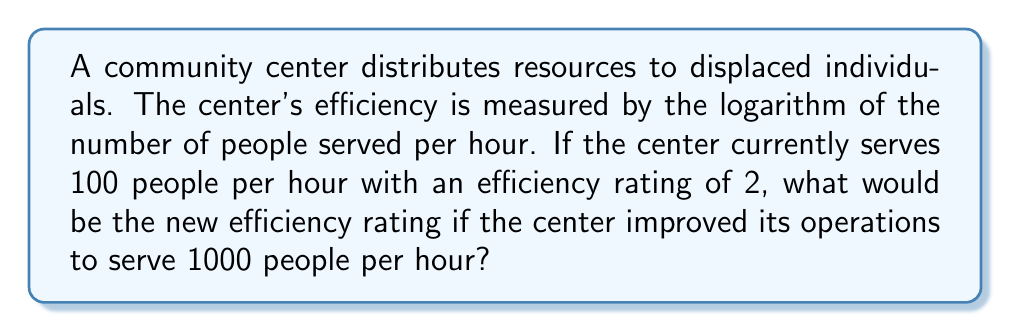Help me with this question. Let's approach this step-by-step:

1) We're given that the efficiency rating is based on the logarithm of the number of people served per hour.

2) The current situation:
   - 100 people served per hour
   - Efficiency rating of 2

3) This means that:
   $$ \log_{b}(100) = 2 $$
   Where $b$ is the base of the logarithm.

4) To find the base, we can solve this equation:
   $$ b^2 = 100 $$
   $$ b = \sqrt{100} = 10 $$

5) So, the efficiency rating is calculated using $\log_{10}$.

6) For the improved situation (1000 people per hour), we calculate:
   $$ \text{New Efficiency} = \log_{10}(1000) $$

7) We know that:
   $$ \log_{10}(1000) = 3 $$
   Because $10^3 = 1000$

Therefore, the new efficiency rating would be 3.
Answer: 3 